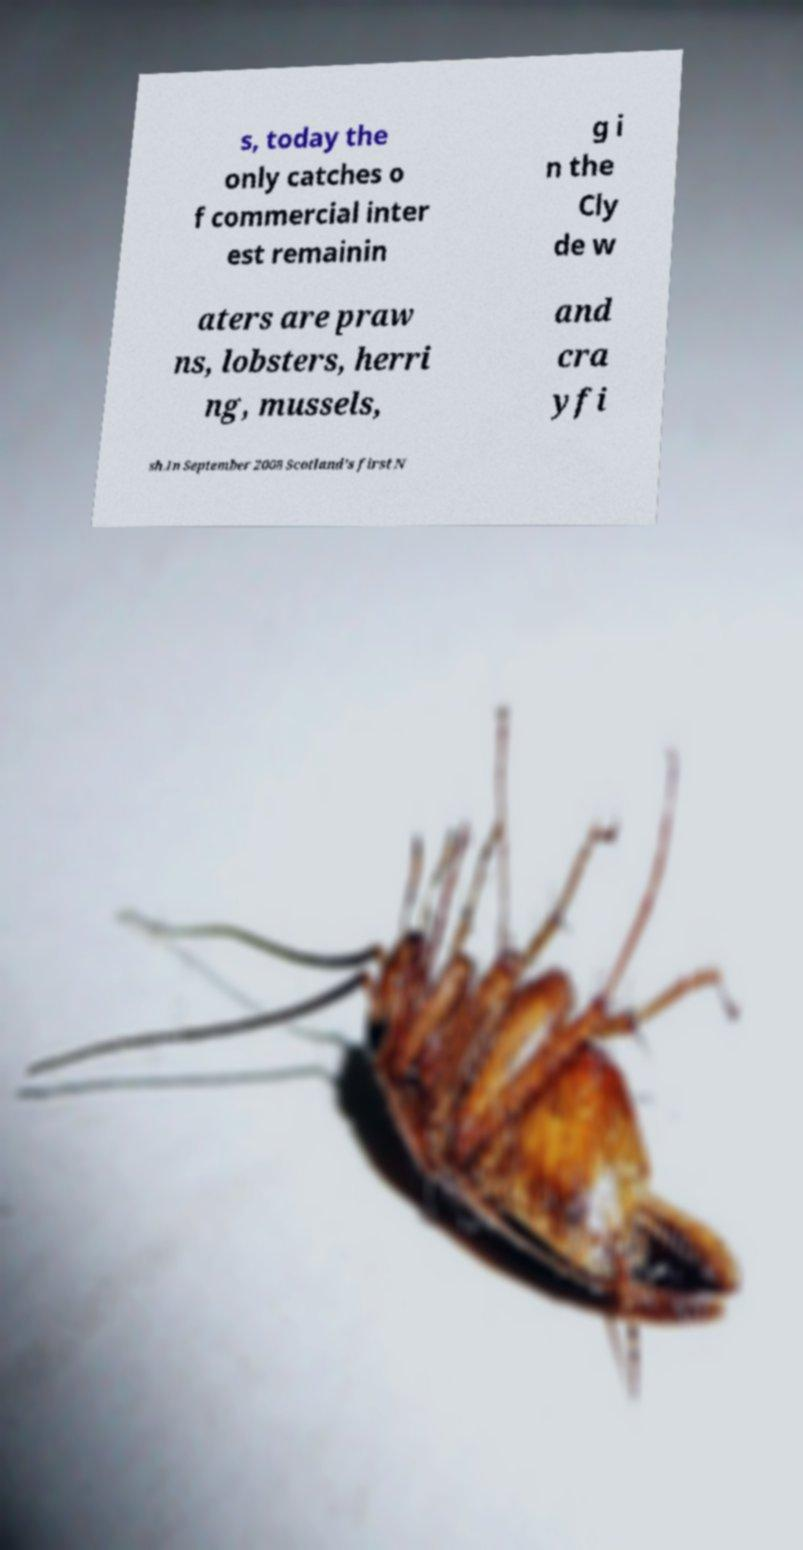Could you assist in decoding the text presented in this image and type it out clearly? s, today the only catches o f commercial inter est remainin g i n the Cly de w aters are praw ns, lobsters, herri ng, mussels, and cra yfi sh.In September 2008 Scotland's first N 